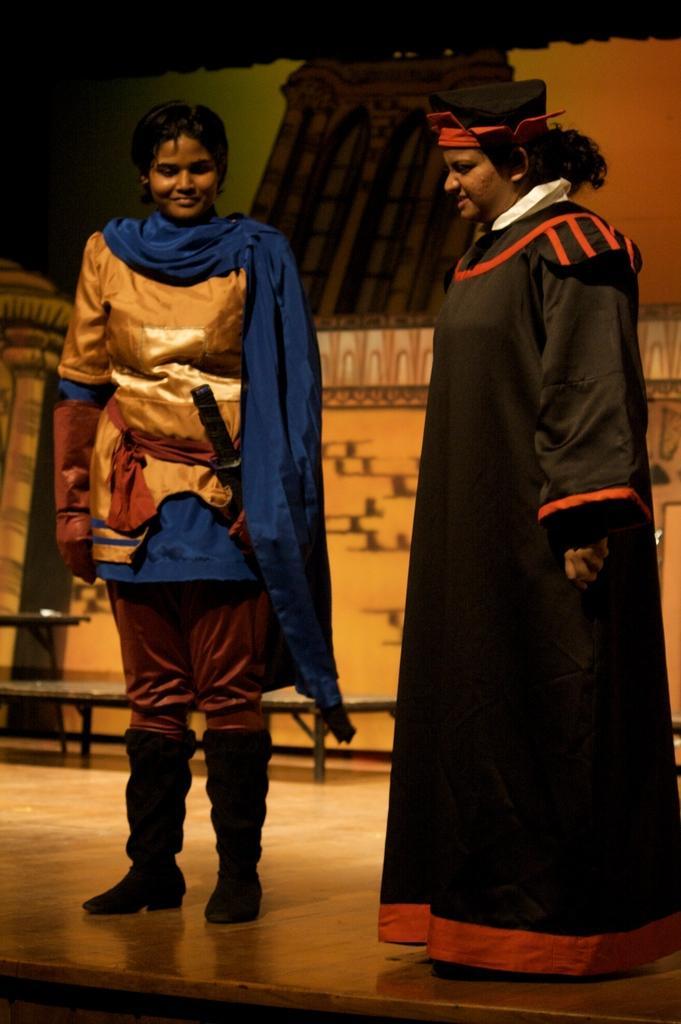In one or two sentences, can you explain what this image depicts? In this image in the center there are persons standing. In the background there is a stage and there is a bench. In the front on the left side the person is standing and smiling. 